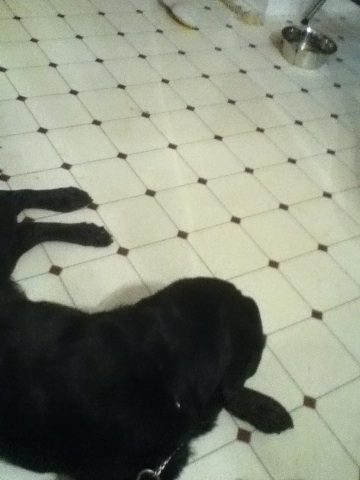Okay, what is that? The image shows a black dog lying on a tiled floor, with a metal pet food bowl nearby. Another dog's leg is partially visible in the background. 